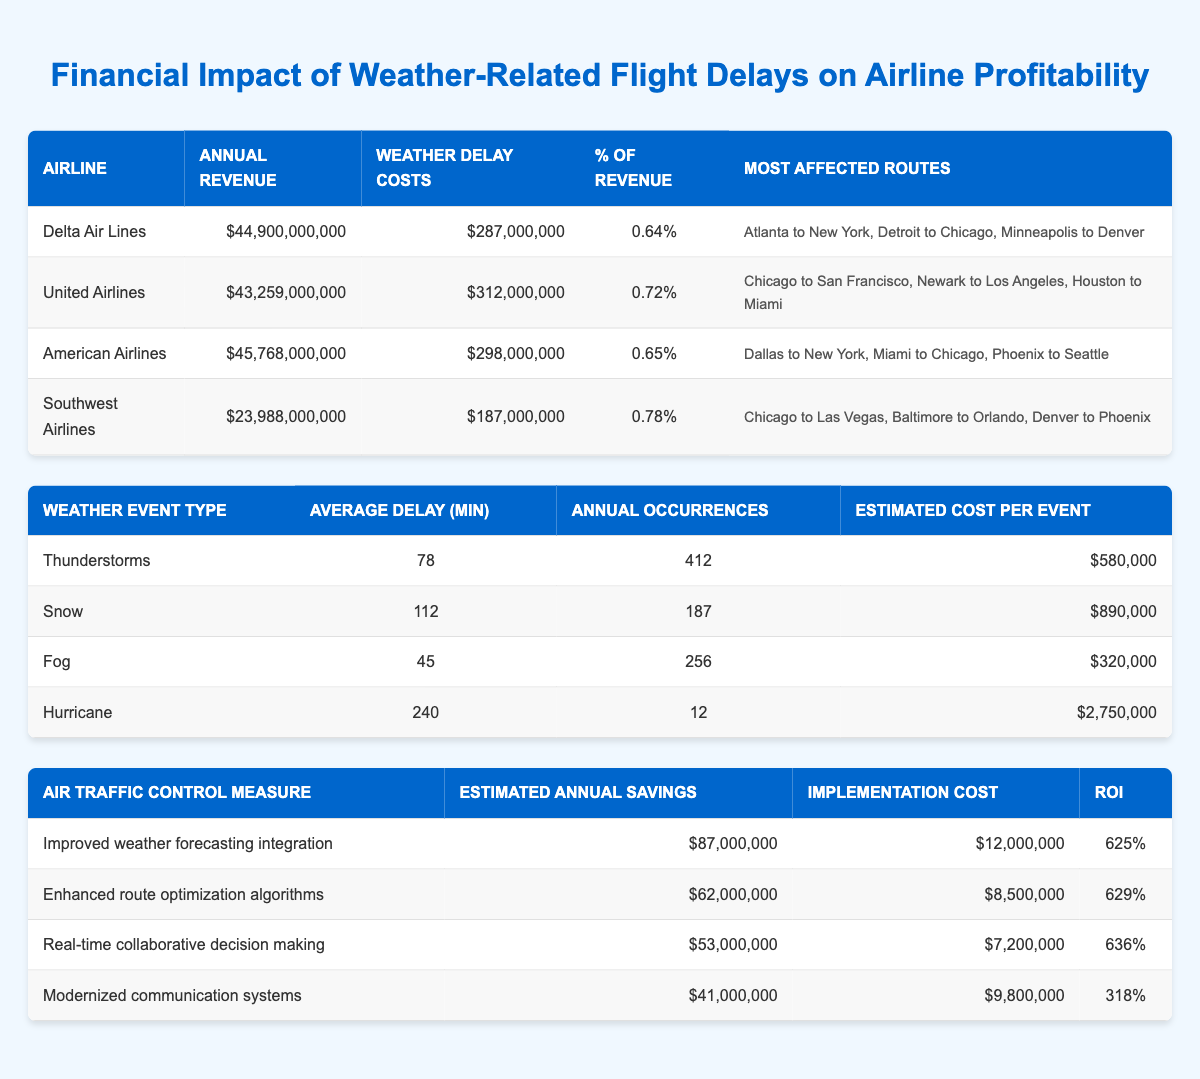What is the total weather delay cost incurred by all airlines listed? To find the total weather delay cost, add the weather delay costs together: $287,000,000 (Delta Air Lines) + $312,000,000 (United Airlines) + $298,000,000 (American Airlines) + $187,000,000 (Southwest Airlines) = $1,084,000,000
Answer: $1,084,000,000 Which airline has the highest percentage of revenue attributed to weather delay costs? Looking at the percentage of revenue for each airline, Southwest Airlines has 0.78%, which is higher than Delta Air Lines (0.64%), United Airlines (0.72%), and American Airlines (0.65%). Therefore, Southwest Airlines has the highest percentage.
Answer: Southwest Airlines Is it true that snow causes the highest average delay minutes among the weather events listed? The average delay minutes for snow is 112, while for thunderstorms it is 78, for fog it is 45, and for hurricanes it is 240. Therefore, hurricanes cause the highest average delay minutes, making the statement false.
Answer: False What is the ROI for the enhanced route optimization algorithms? The ROI for enhanced route optimization algorithms is given in the table as 629%.
Answer: 629% Which airline experienced the highest annual revenue? By comparing the annual revenues listed, American Airlines has $45,768,000,000, which is higher than Delta Air Lines ($44,900,000,000), United Airlines ($43,259,000,000), and Southwest Airlines ($23,988,000,000).
Answer: American Airlines If the weather delay costs for United Airlines and Delta Air Lines are combined, what is the total? Add the weather delay costs for United Airlines ($312,000,000) and Delta Air Lines ($287,000,000): $312,000,000 + $287,000,000 = $599,000,000.
Answer: $599,000,000 Among the weather events, which has the highest estimated cost per event? Looking at the estimated cost per event: Thunderstorms ($580,000), Snow ($890,000), Fog ($320,000), and Hurricanes ($2,750,000), hurricanes have the highest estimated cost per event.
Answer: Hurricanes What are the most affected routes for American Airlines? The most affected routes for American Airlines listed in the table are Dallas to New York, Miami to Chicago, and Phoenix to Seattle.
Answer: Dallas to New York, Miami to Chicago, Phoenix to Seattle Is the implementation cost for improved weather forecasting integration higher than that for modernized communication systems? The implementation cost for improved weather forecasting integration is $12,000,000, while modernized communication systems cost $9,800,000. Therefore, the implementation cost for improved weather forecasting integration is indeed higher.
Answer: Yes 